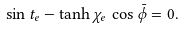Convert formula to latex. <formula><loc_0><loc_0><loc_500><loc_500>\sin t _ { e } - \tanh \chi _ { e } \, \cos \bar { \phi } = 0 .</formula> 